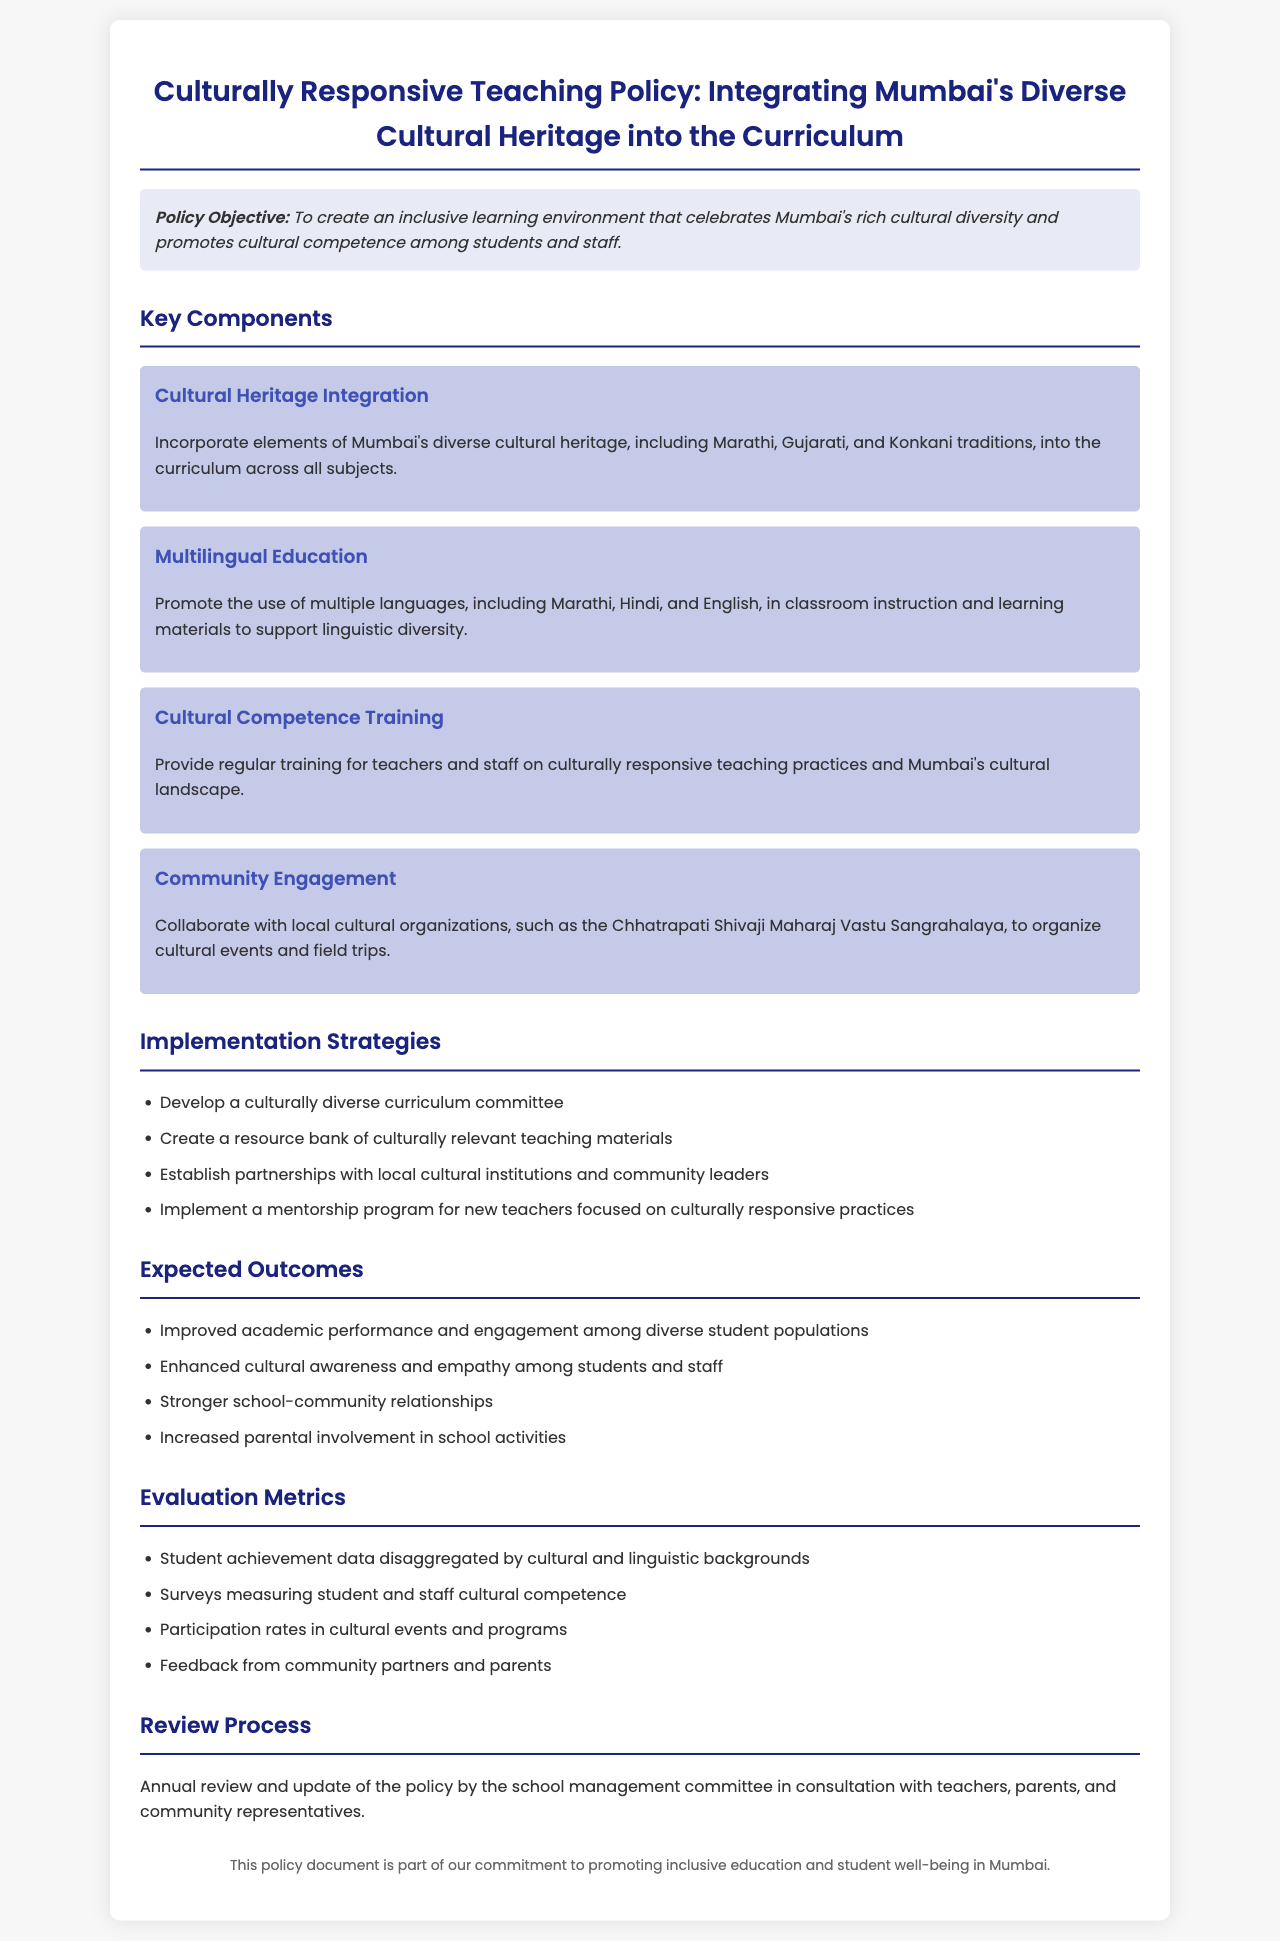What is the policy objective? The policy objective is to create an inclusive learning environment that celebrates Mumbai's rich cultural diversity and promotes cultural competence among students and staff.
Answer: To create an inclusive learning environment What types of traditions are integrated into the curriculum? The curriculum incorporates elements of Mumbai's diverse cultural heritage, including Marathi, Gujarati, and Konkani traditions.
Answer: Marathi, Gujarati, and Konkani Which languages are promoted in multilingual education? The policy promotes the use of multiple languages, including Marathi, Hindi, and English, in classroom instruction and learning materials.
Answer: Marathi, Hindi, and English What is one implementation strategy mentioned? The document lists several implementation strategies; one of them is to develop a culturally diverse curriculum committee.
Answer: Develop a culturally diverse curriculum committee What is one expected outcome? The expected outcomes include improved academic performance among diverse student populations.
Answer: Improved academic performance How often will the policy be reviewed? The policy will be reviewed annually by the school management committee in consultation with stakeholders.
Answer: Annually What type of organizations does the policy suggest collaborating with? The policy suggests collaborating with local cultural organizations, such as the Chhatrapati Shivaji Maharaj Vastu Sangrahalaya.
Answer: Local cultural organizations What is the primary goal of cultural competence training? The primary goal is to provide regular training for teachers and staff on culturally responsive teaching practices and Mumbai's cultural landscape.
Answer: Culturally responsive teaching practices What type of data will be used for evaluation metrics? The evaluation metrics will include student achievement data disaggregated by cultural and linguistic backgrounds.
Answer: Student achievement data 